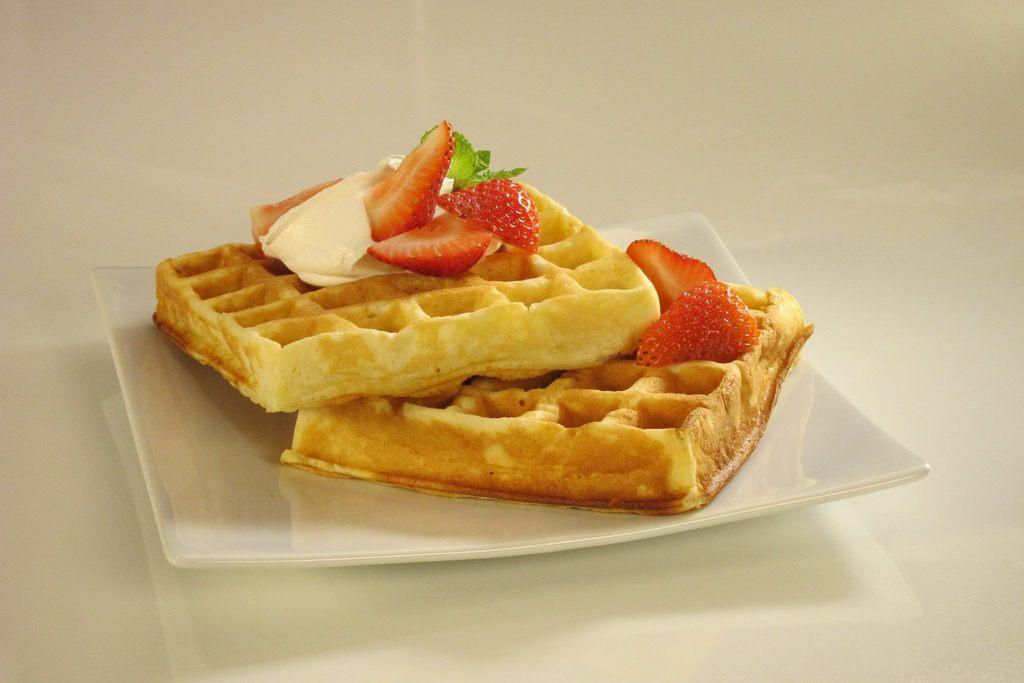What is on the plate that is visible in the image? There are pieces of strawberry on the plate. What type of food is present on the plate? There is food present on the plate. What is the surface at the bottom of the image? The surface at the bottom of the image is not specified, but it could be a table, countertop, or other flat surface. How does the curtain react to the laughter in the image? There is no curtain or laughter present in the image. 